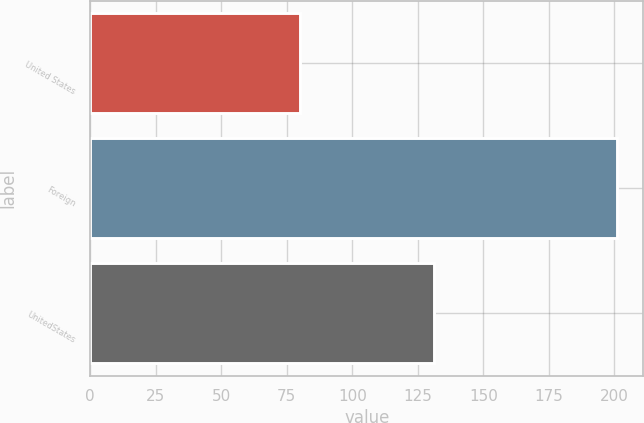Convert chart. <chart><loc_0><loc_0><loc_500><loc_500><bar_chart><fcel>United States<fcel>Foreign<fcel>UnitedStates<nl><fcel>80<fcel>201<fcel>131<nl></chart> 